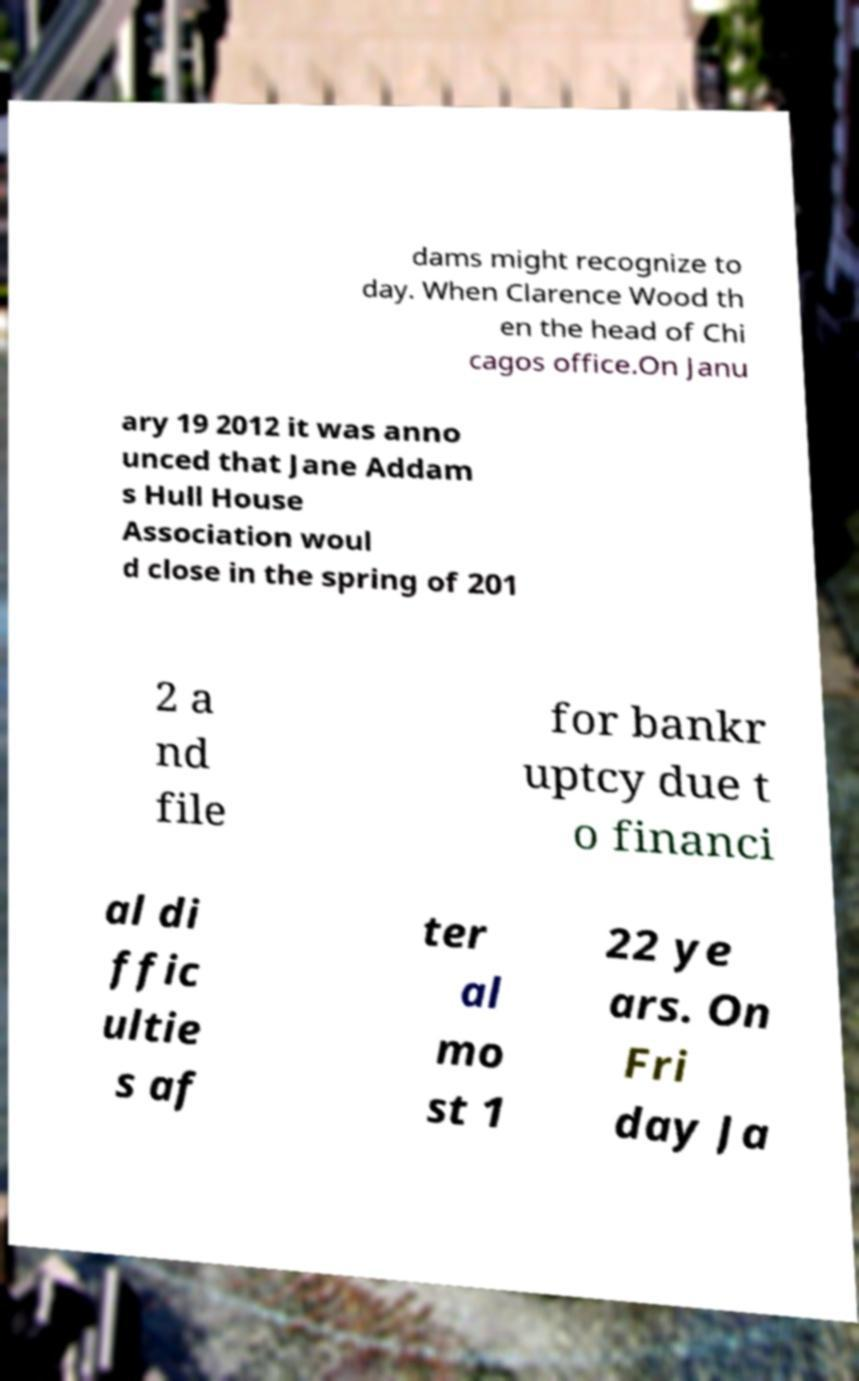I need the written content from this picture converted into text. Can you do that? dams might recognize to day. When Clarence Wood th en the head of Chi cagos office.On Janu ary 19 2012 it was anno unced that Jane Addam s Hull House Association woul d close in the spring of 201 2 a nd file for bankr uptcy due t o financi al di ffic ultie s af ter al mo st 1 22 ye ars. On Fri day Ja 